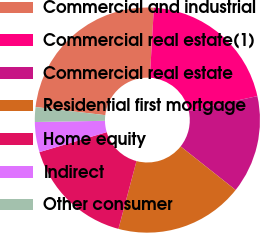Convert chart. <chart><loc_0><loc_0><loc_500><loc_500><pie_chart><fcel>Commercial and industrial<fcel>Commercial real estate(1)<fcel>Commercial real estate<fcel>Residential first mortgage<fcel>Home equity<fcel>Indirect<fcel>Other consumer<nl><fcel>24.07%<fcel>20.66%<fcel>14.08%<fcel>18.47%<fcel>16.27%<fcel>4.32%<fcel>2.12%<nl></chart> 